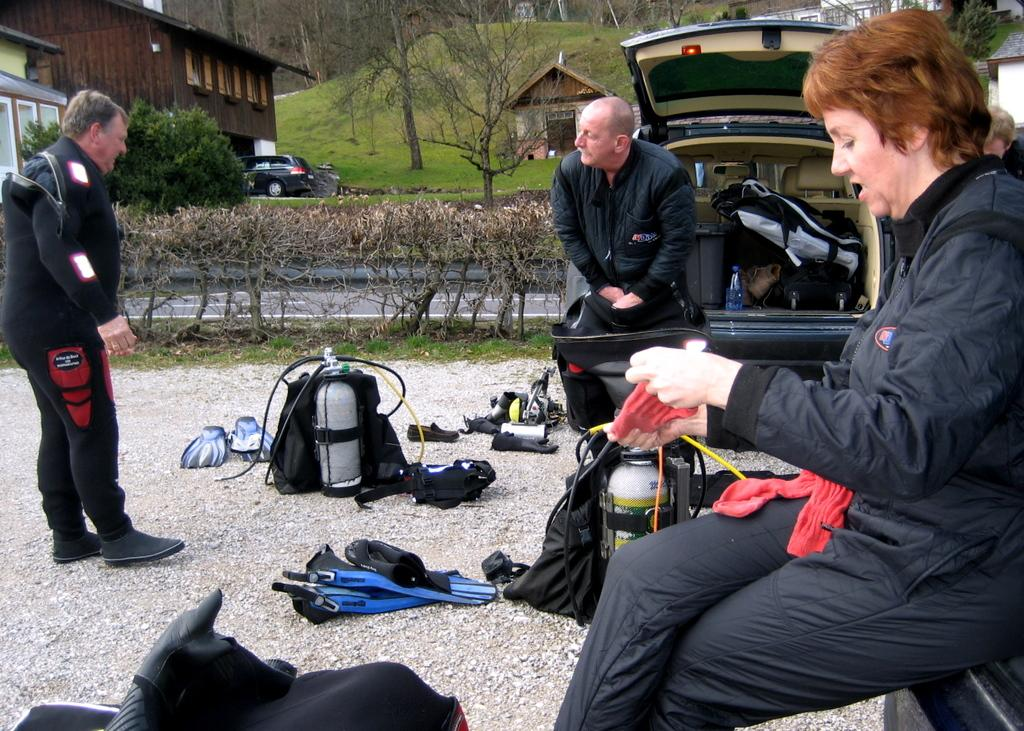What can be seen on the ground in the image? There are people on the ground in the image. What else is present in the image besides people? There are vehicles and objects in the image. What can be seen in the background of the image? There are buildings and trees in the background of the image. What type of chalk is being used to draw on the trees in the background? There is no chalk or drawing activity present in the image; it features people, vehicles, objects, buildings, and trees. How many pieces of pie are visible on the ground in the image? There is no pie present in the image; it features people, vehicles, objects, buildings, and trees. 